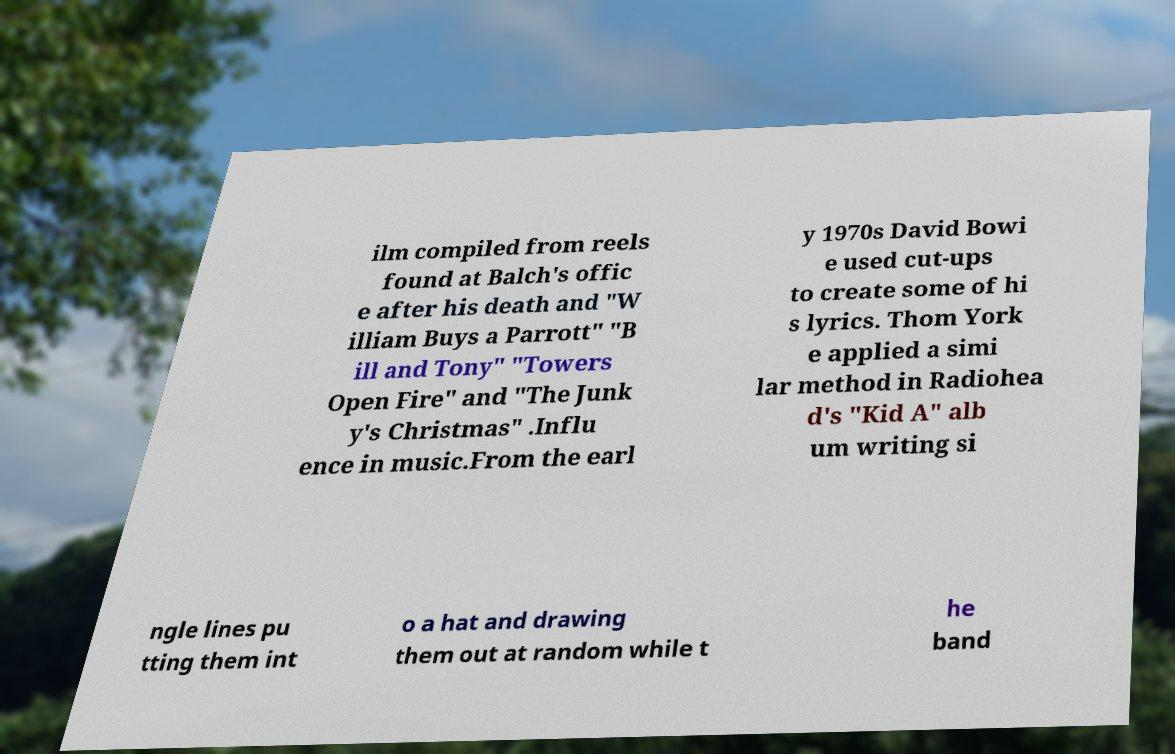Could you assist in decoding the text presented in this image and type it out clearly? ilm compiled from reels found at Balch's offic e after his death and "W illiam Buys a Parrott" "B ill and Tony" "Towers Open Fire" and "The Junk y's Christmas" .Influ ence in music.From the earl y 1970s David Bowi e used cut-ups to create some of hi s lyrics. Thom York e applied a simi lar method in Radiohea d's "Kid A" alb um writing si ngle lines pu tting them int o a hat and drawing them out at random while t he band 